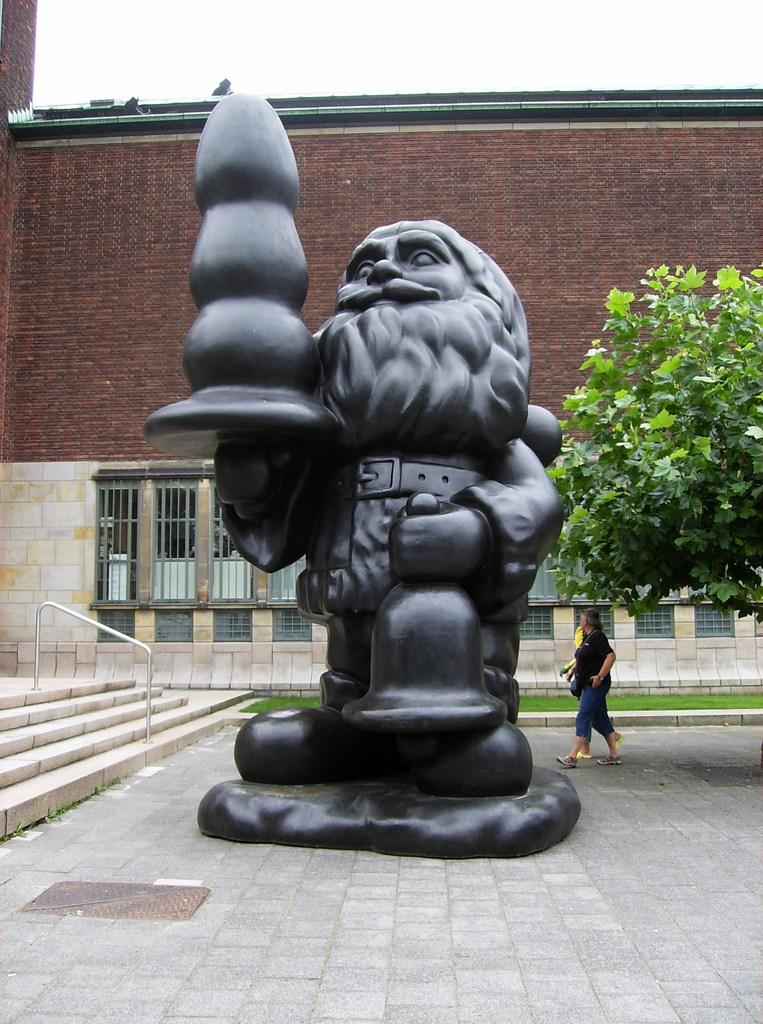What is the main subject in the center of the image? There is a black color statue in the center of the image. Where is the statue located? The statue is on the ground. What can be seen in the background of the image? There is a building, a tree, persons, stairs, and the sky visible in the background of the image. How many cattle are present in the image? There are no cattle present in the image. What type of street can be seen in the image? There is no street visible in the image. 